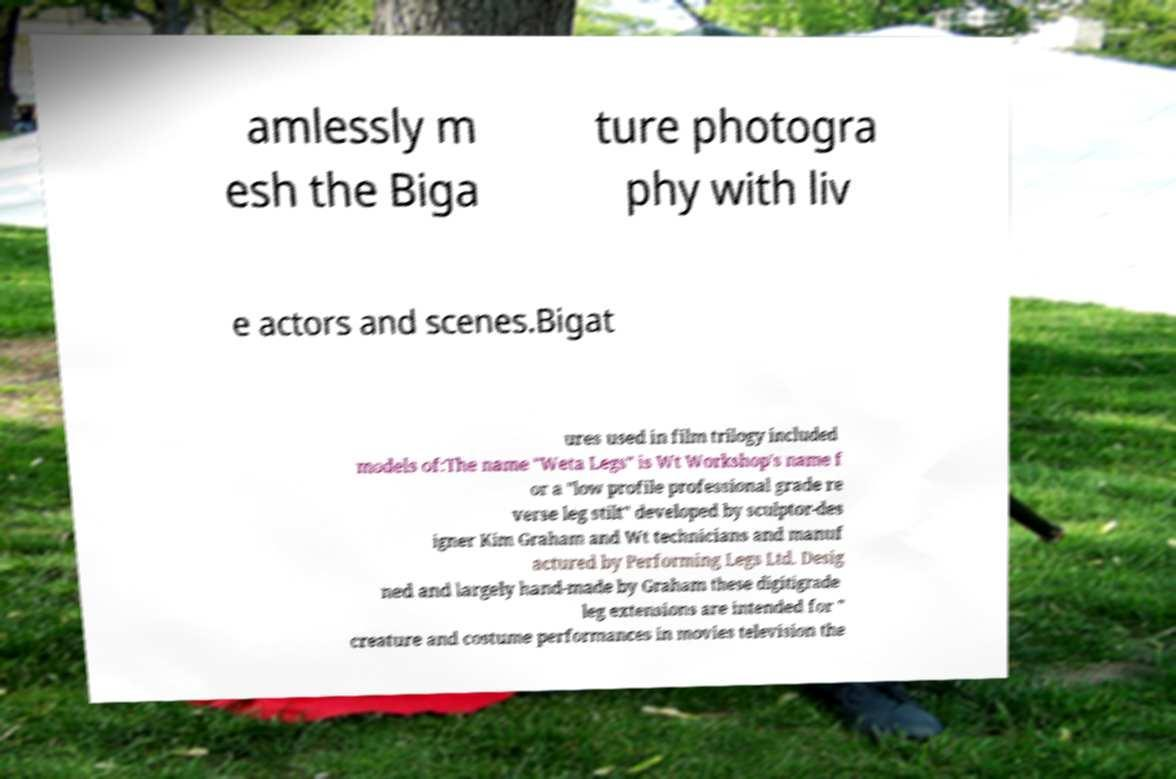Could you assist in decoding the text presented in this image and type it out clearly? amlessly m esh the Biga ture photogra phy with liv e actors and scenes.Bigat ures used in film trilogy included models of:The name "Weta Legs" is Wt Workshop's name f or a "low profile professional grade re verse leg stilt" developed by sculptor-des igner Kim Graham and Wt technicians and manuf actured by Performing Legs Ltd. Desig ned and largely hand-made by Graham these digitigrade leg extensions are intended for " creature and costume performances in movies television the 